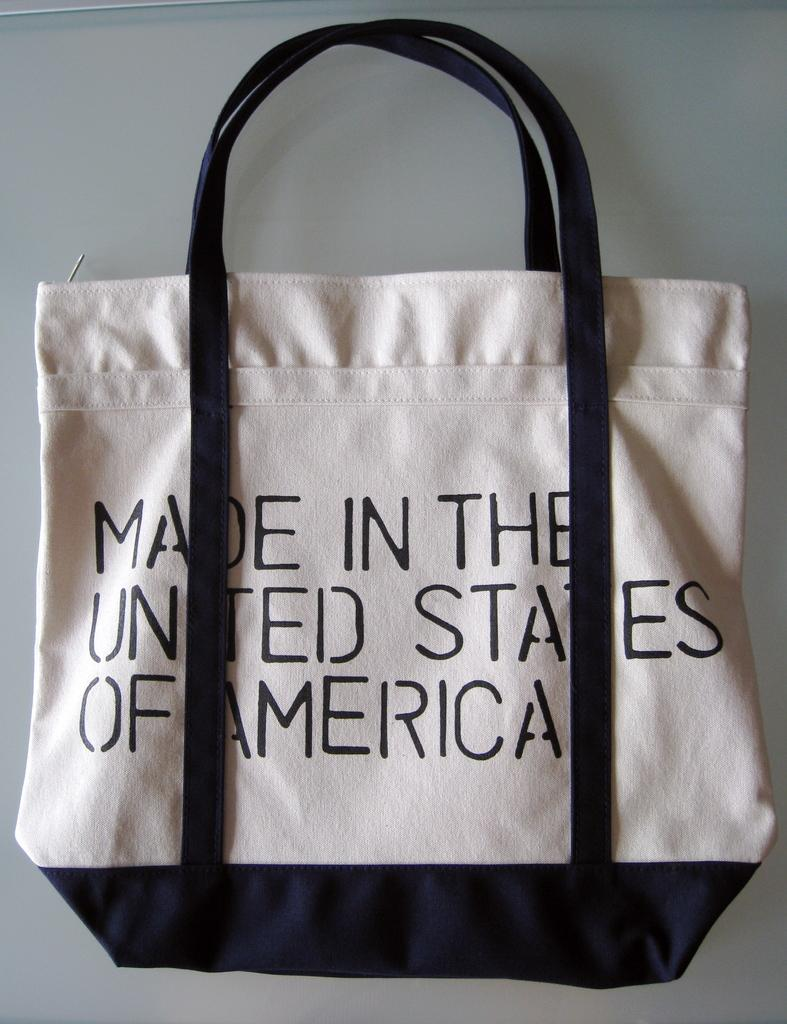What color is the bag in the image? The bag in the image is white. What can be seen on the handles of the bag? The handles of the bag are black. Where is the text "Made in the United States of America" located on the bag? The text is written on the back of the bag. How many dimes are visible inside the bag in the image? There are no dimes visible inside the bag in the image. What is the way to the nearest store from the location of the bag in the image? The image does not provide information about the location of the bag or the nearest store, so we cannot determine the way from the image. 